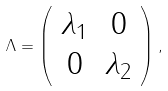<formula> <loc_0><loc_0><loc_500><loc_500>\Lambda = \left ( \begin{array} { c c } \lambda _ { 1 } & 0 \\ 0 & \lambda _ { 2 } \\ \end{array} \right ) ,</formula> 